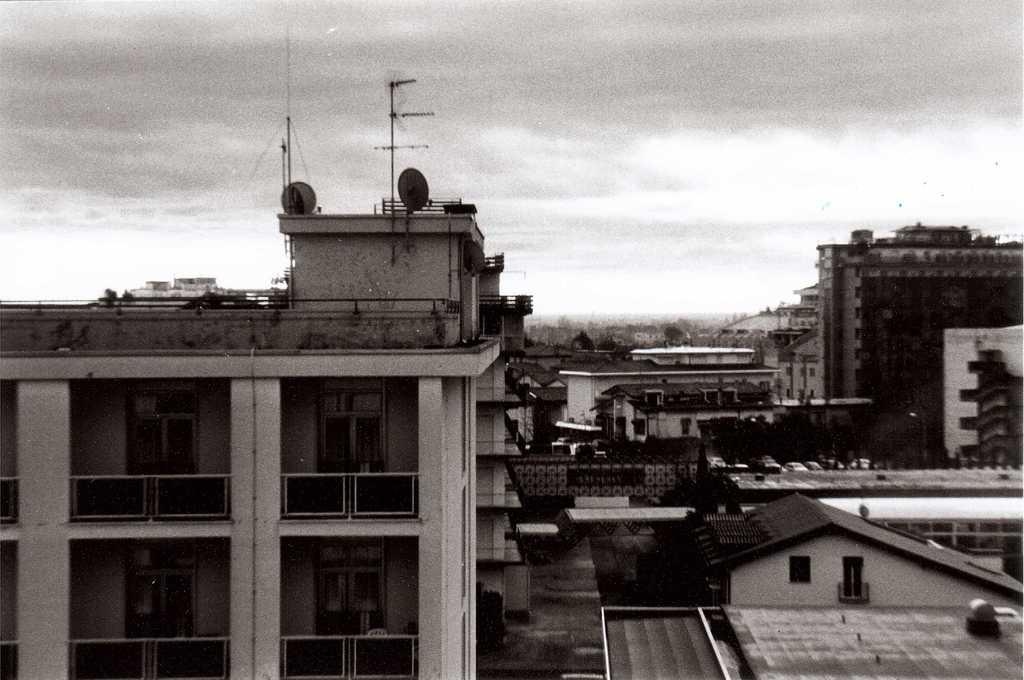What is the color scheme of the image? The image is black and white. What can be seen in the foreground of the image? There are buildings in the foreground of the image. What is visible in the background of the image? The sky is visible in the image. Can you describe the sky in the image? Clouds are present in the sky. What type of food is being served through the window in the image? There is no window or food present in the image; it is a black and white image featuring buildings and a sky with clouds. 